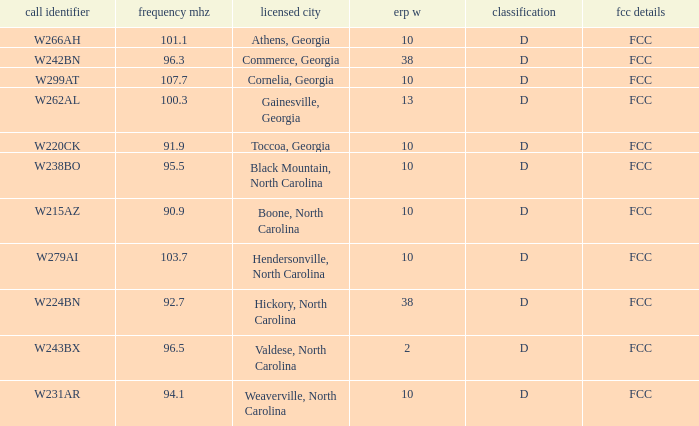What class is the city of black mountain, north carolina? D. 